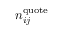<formula> <loc_0><loc_0><loc_500><loc_500>n _ { i j } ^ { q u o t e }</formula> 